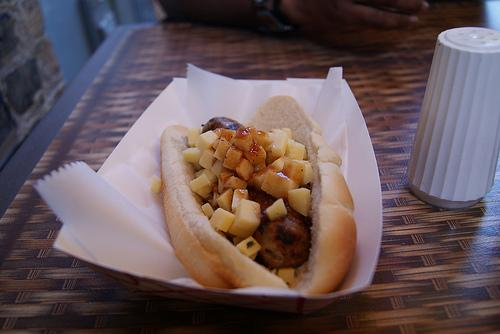How many objects related to food are there in the image, and what are their characteristics? There are 11 food-related objects: hot dog on bun, white cubed cheese topping, piece of cheese, sausage, and 5 pieces of fruit. They are served with various toppings and placed on a plate with paper. Explain the purpose of the main object in the image and its components. The main object is a hot dog on a bun, served with white cheese and a dark sauce as toppings, on a plate with a paper towel, and is intended for eating at the restaurant dining table. What sentiments can be inferred from the objects in the given image? The image conveys a casual, relaxed dining environment at a restaurant, with a person ready to enjoy their hot dog meal. What features can be recognized in the immediate surroundings of the main object? A white wax paper, a paper tray with red and white stripe design, a table with a wicker-patterned place mat, a salt shaker, and a person's hand with a watch on their wrist. Provide a brief description of the scene containing the main object. A hot dog with cheese and sauce is placed in a paper tray on a restaurant dining table which also has a salt shaker and a person with a watch on their wrist resting their hand on the table. Evaluate the quality of the presentation of the main object and its surroundings. The presentation is visually appealing and organized, with toppings properly placed and various components like wax paper and paper tray keeping the meal tidy. Analyze the interaction between objects in the image and their respective purposes. The hot dog on a bun with toppings is served on wax paper in a paper tray for hygiene and easy handling. The person at the table is likely to eat the hot dog using their hand, which has a watch on it. A salt shaker is nearby for seasoning if needed. Perform a complex reasoning task: what assumptions can be made about the person eating the hot dog based on the information given? The person eating the hot dog might prefer a casual dining experience and may favor foods like hot dogs with various toppings. They also wear a watch, which could suggest punctuality or style preference. Can you spot the green apple on the plate next to the hot dog? There's a fresh green apple placed neatly beside the hot dog, providing a healthy contrast to the meal. Can you find the neon sign with the word "Diner" hanging on the wall behind the table? The vibrant neon sign announces the location of the dining establishment where the hot dog meal is being enjoyed. Do you see the glass of ice-cold lemonade next to the salt shaker on the table? A refreshing glass of lemonade with ice cubes awaits the person seated at the table, complementing their hot dog meal. Look for the blue umbrella hovering above the table, shielding the food from the sun. A large blue umbrella is open above the table, casting a cooling shade on the delectable hot dog meal. Notice the cute golden retriever sitting under the table, waiting for some fallen food. The well-behaved dog rests patiently under the table, hoping for a delicious morsel to drop from the hot dog meal. Observe the chef in the background expertly flipping burgers on a sizzling grill. The talented chef prepares delicious burgers with finesse, as the diner indulges in their hot dog meal. 